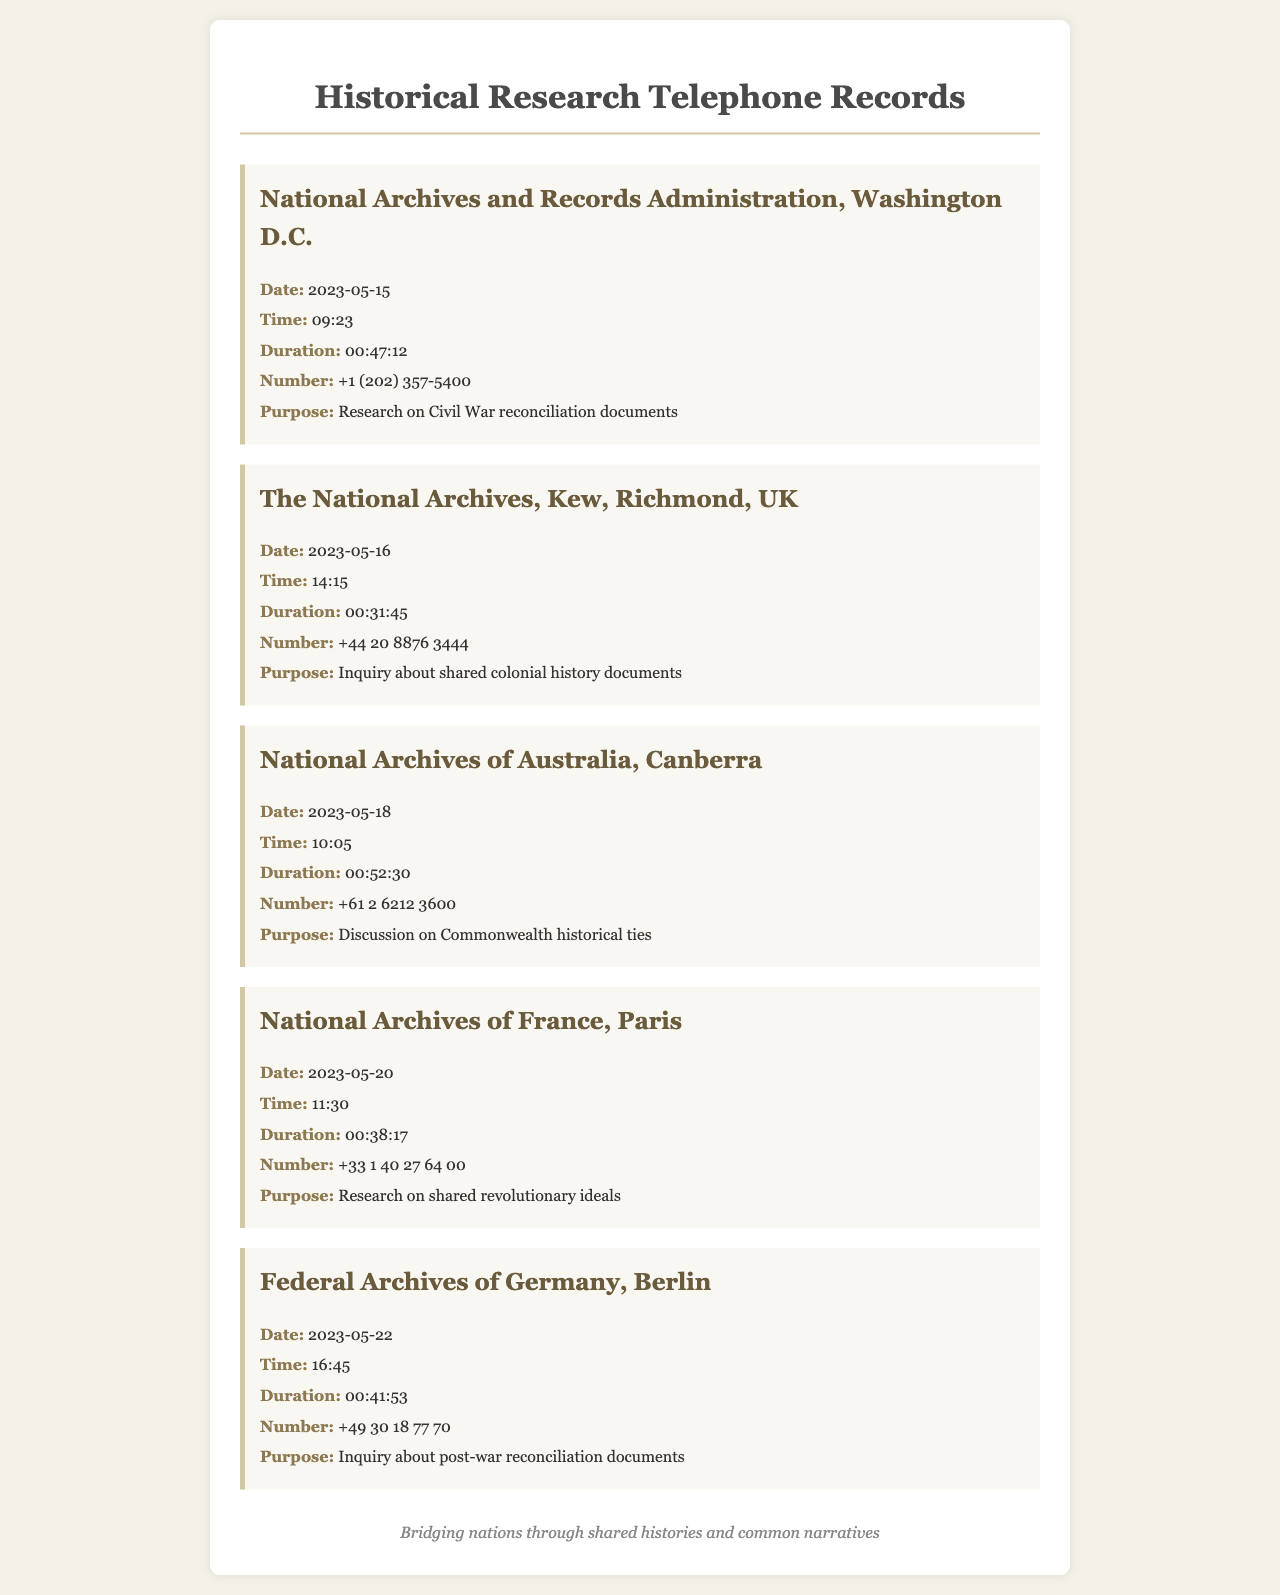What is the date of the first call? The first call listed in the records was made on May 15, 2023.
Answer: 2023-05-15 What was the duration of the call to the National Archives of France? The duration of the call to the National Archives of France is specified in the document as 38 minutes and 17 seconds.
Answer: 00:38:17 Who did the call on May 20, 2023, concern? The call on May 20, 2023, was made to the National Archives of France regarding shared revolutionary ideals.
Answer: National Archives of France How long was the call to the National Archives of Australia? The call duration to the National Archives of Australia is outlined as 52 minutes and 30 seconds.
Answer: 00:52:30 What was the purpose of the call made to the Federal Archives of Germany? The purpose of the call to the Federal Archives of Germany was to inquire about post-war reconciliation documents.
Answer: Inquiry about post-war reconciliation documents What time was the call made to The National Archives, Kew? The call to The National Archives, Kew was made at 14:15.
Answer: 14:15 Which national archive had the longest call duration? The call to the National Archives of Australia had the longest duration, which is noted in the records.
Answer: National Archives of Australia What is the area code for the National Archives and Records Administration? The area code for the National Archives and Records Administration is +1.
Answer: +1 